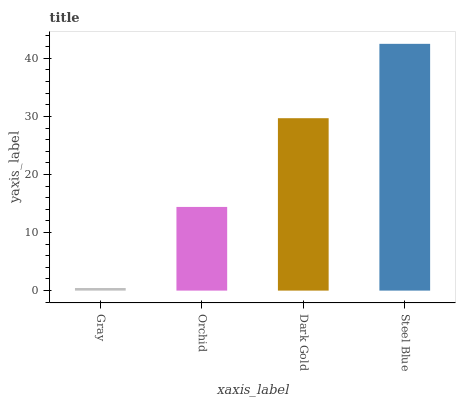Is Gray the minimum?
Answer yes or no. Yes. Is Steel Blue the maximum?
Answer yes or no. Yes. Is Orchid the minimum?
Answer yes or no. No. Is Orchid the maximum?
Answer yes or no. No. Is Orchid greater than Gray?
Answer yes or no. Yes. Is Gray less than Orchid?
Answer yes or no. Yes. Is Gray greater than Orchid?
Answer yes or no. No. Is Orchid less than Gray?
Answer yes or no. No. Is Dark Gold the high median?
Answer yes or no. Yes. Is Orchid the low median?
Answer yes or no. Yes. Is Orchid the high median?
Answer yes or no. No. Is Dark Gold the low median?
Answer yes or no. No. 